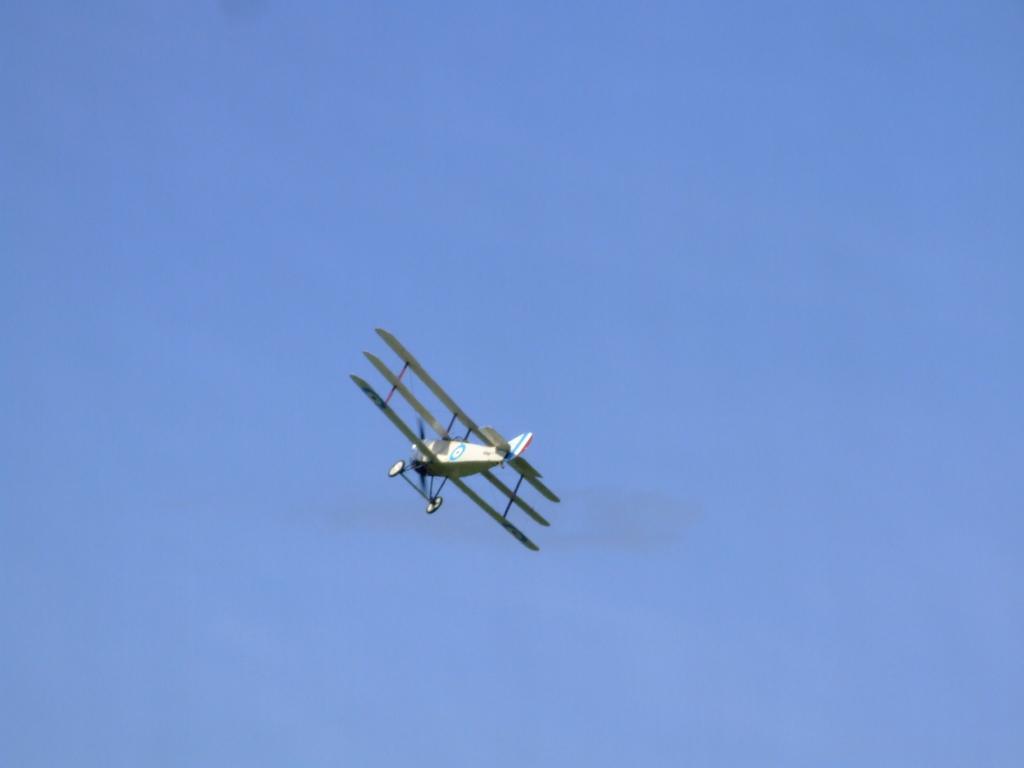Could you give a brief overview of what you see in this image? In this picture, we can see an aircraft flying and we can see the sky. 